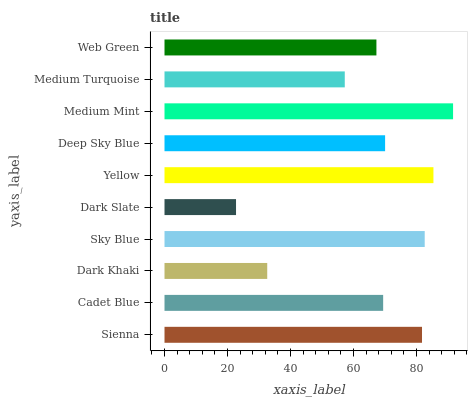Is Dark Slate the minimum?
Answer yes or no. Yes. Is Medium Mint the maximum?
Answer yes or no. Yes. Is Cadet Blue the minimum?
Answer yes or no. No. Is Cadet Blue the maximum?
Answer yes or no. No. Is Sienna greater than Cadet Blue?
Answer yes or no. Yes. Is Cadet Blue less than Sienna?
Answer yes or no. Yes. Is Cadet Blue greater than Sienna?
Answer yes or no. No. Is Sienna less than Cadet Blue?
Answer yes or no. No. Is Deep Sky Blue the high median?
Answer yes or no. Yes. Is Cadet Blue the low median?
Answer yes or no. Yes. Is Sienna the high median?
Answer yes or no. No. Is Yellow the low median?
Answer yes or no. No. 